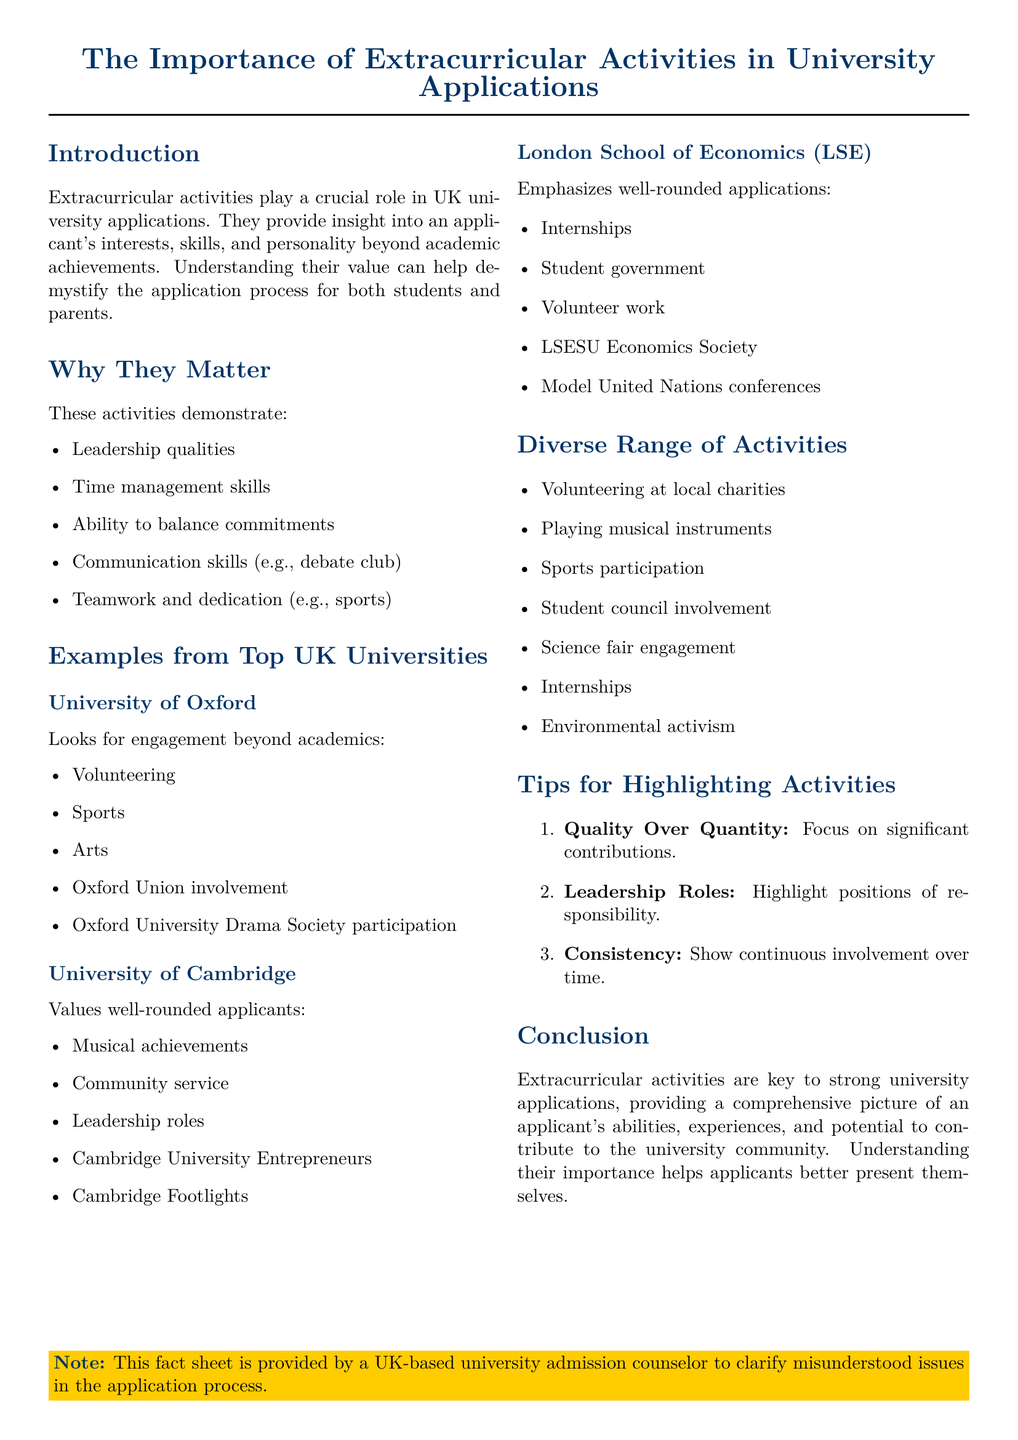What is the primary focus of extracurricular activities in university applications? The primary focus is on providing insight into an applicant's interests, skills, and personality beyond academic achievements.
Answer: Insight into interests, skills, and personality Which university looks for engagement beyond academics? The document lists the University of Oxford as looking for this engagement.
Answer: University of Oxford Name one type of activity valued by the University of Cambridge. The document states that community service is one type of activity valued by the University of Cambridge.
Answer: Community service What is emphasized by the London School of Economics regarding applications? The emphasis is on well-rounded applications.
Answer: Well-rounded applications What type of extracurricular involvement showcases leadership roles? Positions of responsibility highlight leadership roles.
Answer: Positions of responsibility According to the tips, what is more important when highlighting activities? The document suggests that quality is more important than quantity when highlighting activities.
Answer: Quality over quantity List one example of a diverse activity mentioned in the document. Volunteering at local charities is one example provided in the document.
Answer: Volunteering at local charities How many tips are provided for highlighting activities? The document outlines three tips for highlighting activities.
Answer: Three tips What societal aspect do extracurricular activities help demonstrate in applicants? They help demonstrate communication skills among other qualities.
Answer: Communication skills 